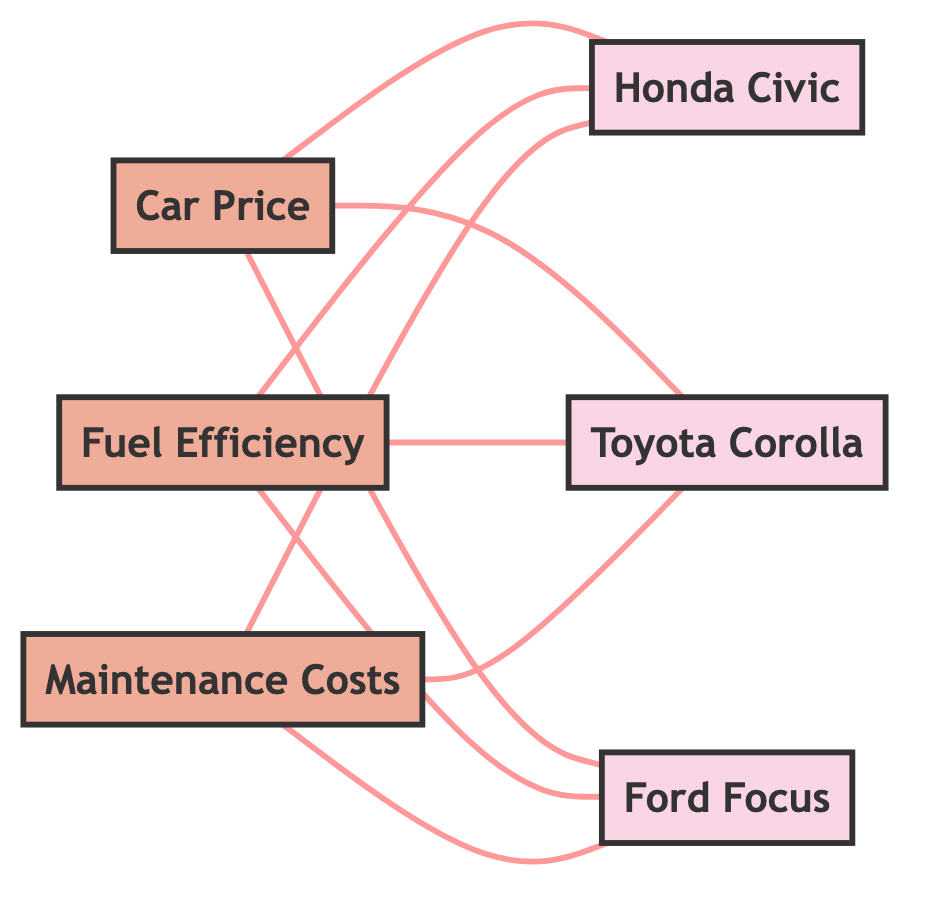What are the main nodes in the diagram? The main nodes in the diagram are "Car Price", "Fuel Efficiency", "Maintenance Costs", "Honda Civic", "Toyota Corolla", and "Ford Focus". These nodes represent key factors related to the connection between car price, fuel efficiency, and maintenance costs.
Answer: Car Price, Fuel Efficiency, Maintenance Costs, Honda Civic, Toyota Corolla, Ford Focus How many edges are there connecting nodes in this graph? The diagram has a total of nine edges, which represent the relationships between the factors (Car Price, Fuel Efficiency, Maintenance Costs) and the car models (Honda Civic, Toyota Corolla, Ford Focus). Each edge indicates that one factor affects a specific car model.
Answer: Nine Which car model is affected by both Maintenance Costs and Fuel Efficiency? The car models that are affected by both Maintenance Costs and Fuel Efficiency are the Honda Civic, Toyota Corolla, and Ford Focus, as shown by the multiple edges connecting them to both factors.
Answer: Honda Civic, Toyota Corolla, Ford Focus What is the relationship between Fuel Efficiency and Toyota Corolla? The relationship is "affects." This indicates that the factor of Fuel Efficiency has an impact on the Toyota Corolla in terms of its performance and operational costs.
Answer: Affects Which node has the most connections in this graph? The nodes "Car Price", "Fuel Efficiency", and "Maintenance Costs" each have three connections, corresponding to their relationships with the three car models.
Answer: Car Price, Fuel Efficiency, Maintenance Costs If the Maintenance Costs decrease, which car models will it affect? A decrease in Maintenance Costs will affect all three car models: Honda Civic, Toyota Corolla, and Ford Focus, as they are all connected to the Maintenance Costs node.
Answer: Honda Civic, Toyota Corolla, Ford Focus What factor is connected to the greatest number of car models? The factors Car Price, Fuel Efficiency, and Maintenance Costs are each connected to three car models, so they are equally connected to the greatest number of car models.
Answer: Car Price, Fuel Efficiency, Maintenance Costs Is there a direct connection between Fuel Efficiency and Maintenance Costs? No, there is no direct connection between Fuel Efficiency and Maintenance Costs in the diagram. Each only connects to the car models directly but not to each other.
Answer: No 